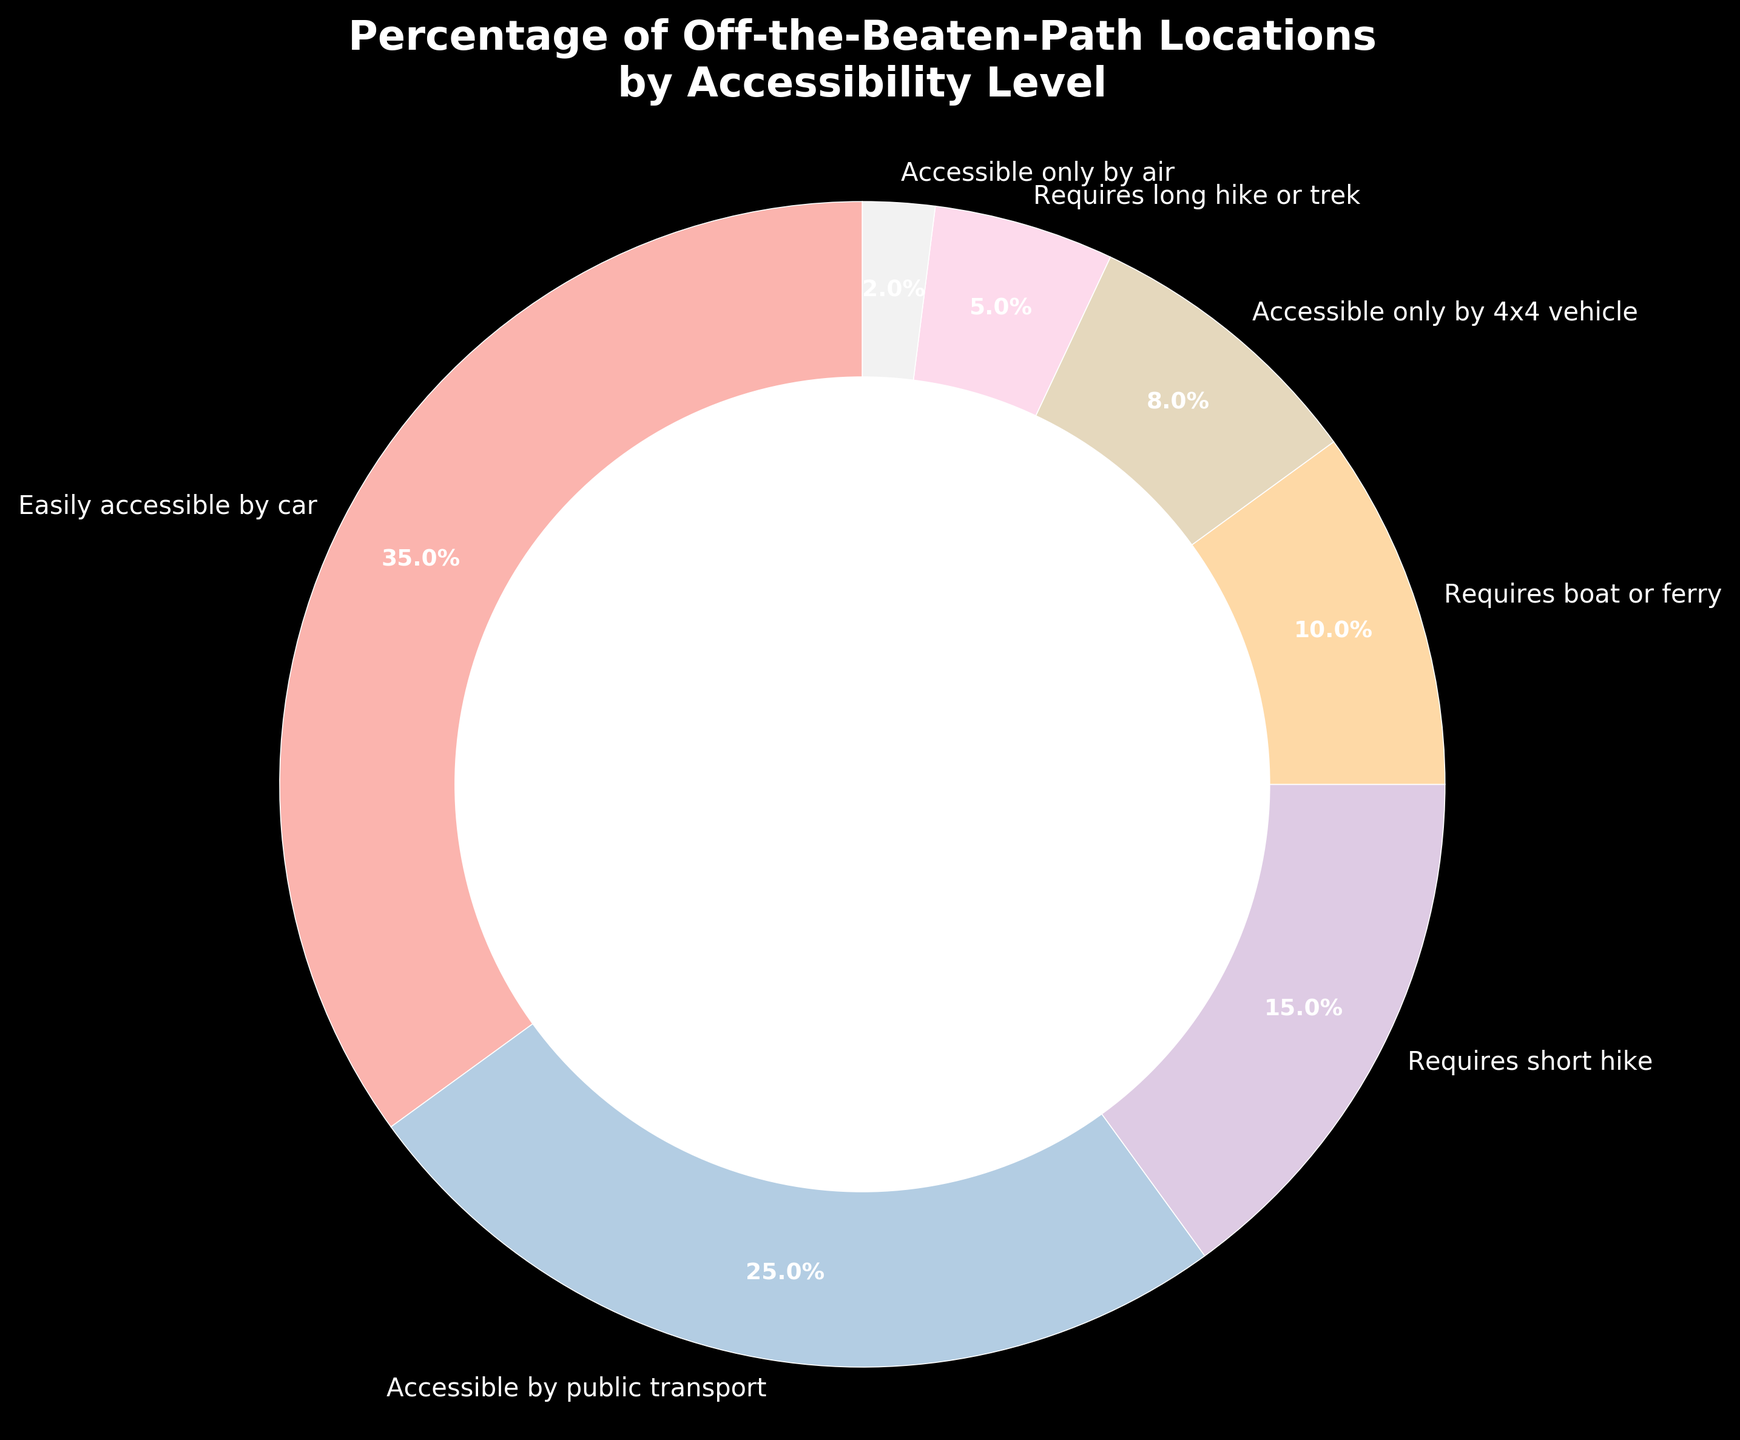what is the combined percentage of locations that require either a short or long hike? Sum the percentages of locations that require a short hike and a long hike, which are 15 and 5, respectively. 15 + 5 = 20
Answer: 20 which accessibility level has the smallest percentage of locations? The figure displays that the smallest segment is for locations that are "Accessible only by air" with a percentage of 2%.
Answer: Accessible only by air Compare the percentages of locations that are easily accessible by car and those accessible by public transport. Which is higher, and by how much? The percentage of locations easily accessible by car is 35%, and the percentage for those accessible by public transport is 25%. To find the difference, subtract 25 from 35. 35 - 25 = 10
Answer: Easily accessible by car, 10 Which accessibility level has a larger percentage: Requires a boat or ferry, or accessible only by 4x4 vehicle? The figure shows that locations requiring a boat or ferry have a percentage of 10%, while places accessible only by 4x4 vehicle have a percentage of 8%. 10 is greater than 8.
Answer: Requires a boat or ferry What is the total percentage of locations that are not accessible by any vehicle (includes boat or ferry)? Sum the percentages of locations that require a short hike, a long hike or trek, or are accessible only by air. 15 + 5 + 2 = 22
Answer: 22 Approximately what fraction of locations are easily accessible by car? The percentage of locations easily accessible by car is 35%. To convert this to a fraction, 35/100 simplifies to 7/20.
Answer: 7/20 How does the percentage of locations requiring a boat or ferry compare to the percentage of locations requiring a short hike? The percentage of locations requiring a boat or ferry is 10%, while those requiring a short hike is 15%. 15 is greater than 10.
Answer: Short hike If you add the percentages of locations accessible by public transport, requiring a boat or ferry, and accessible only by 4x4 vehicle, what is the total? Sum the percentages: 25 + 10 + 8 = 43
Answer: 43 By how much does the percentage of locations requiring a long hike or trek differ from those accessible only by air? The percentage for locations requiring a long hike or trek is 5%, and for those accessible only by air is 2%. The difference is 5 - 2 = 3
Answer: 3 